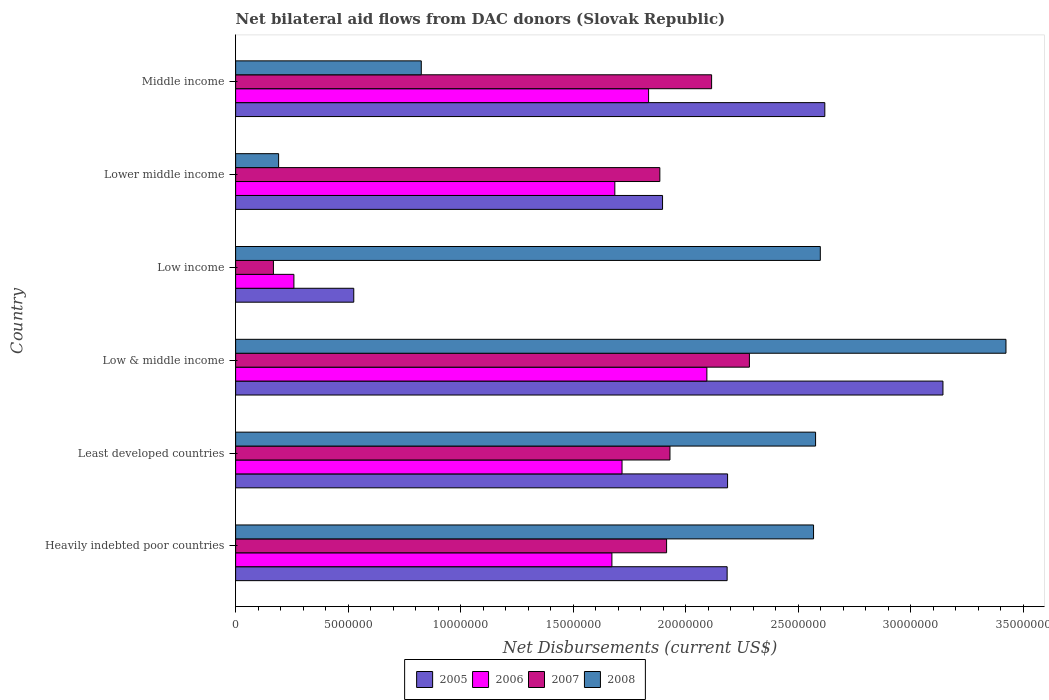How many different coloured bars are there?
Your response must be concise. 4. How many bars are there on the 5th tick from the top?
Provide a short and direct response. 4. How many bars are there on the 6th tick from the bottom?
Your answer should be compact. 4. What is the label of the 3rd group of bars from the top?
Ensure brevity in your answer.  Low income. In how many cases, is the number of bars for a given country not equal to the number of legend labels?
Provide a succinct answer. 0. What is the net bilateral aid flows in 2005 in Low income?
Your answer should be compact. 5.25e+06. Across all countries, what is the maximum net bilateral aid flows in 2005?
Give a very brief answer. 3.14e+07. Across all countries, what is the minimum net bilateral aid flows in 2006?
Offer a very short reply. 2.59e+06. In which country was the net bilateral aid flows in 2007 maximum?
Give a very brief answer. Low & middle income. In which country was the net bilateral aid flows in 2006 minimum?
Your response must be concise. Low income. What is the total net bilateral aid flows in 2007 in the graph?
Offer a terse response. 1.03e+08. What is the difference between the net bilateral aid flows in 2007 in Heavily indebted poor countries and that in Low & middle income?
Your answer should be very brief. -3.68e+06. What is the difference between the net bilateral aid flows in 2008 in Low income and the net bilateral aid flows in 2006 in Low & middle income?
Ensure brevity in your answer.  5.04e+06. What is the average net bilateral aid flows in 2005 per country?
Provide a succinct answer. 2.09e+07. What is the difference between the net bilateral aid flows in 2006 and net bilateral aid flows in 2008 in Middle income?
Give a very brief answer. 1.01e+07. What is the ratio of the net bilateral aid flows in 2008 in Heavily indebted poor countries to that in Middle income?
Provide a short and direct response. 3.11. Is the difference between the net bilateral aid flows in 2006 in Low income and Middle income greater than the difference between the net bilateral aid flows in 2008 in Low income and Middle income?
Offer a terse response. No. What is the difference between the highest and the second highest net bilateral aid flows in 2008?
Offer a terse response. 8.25e+06. What is the difference between the highest and the lowest net bilateral aid flows in 2007?
Your answer should be very brief. 2.12e+07. Is it the case that in every country, the sum of the net bilateral aid flows in 2006 and net bilateral aid flows in 2005 is greater than the sum of net bilateral aid flows in 2008 and net bilateral aid flows in 2007?
Offer a terse response. No. What does the 1st bar from the bottom in Low & middle income represents?
Offer a very short reply. 2005. How many bars are there?
Your answer should be very brief. 24. How many countries are there in the graph?
Keep it short and to the point. 6. Does the graph contain grids?
Make the answer very short. No. How are the legend labels stacked?
Offer a terse response. Horizontal. What is the title of the graph?
Give a very brief answer. Net bilateral aid flows from DAC donors (Slovak Republic). What is the label or title of the X-axis?
Offer a very short reply. Net Disbursements (current US$). What is the Net Disbursements (current US$) in 2005 in Heavily indebted poor countries?
Your response must be concise. 2.18e+07. What is the Net Disbursements (current US$) in 2006 in Heavily indebted poor countries?
Offer a very short reply. 1.67e+07. What is the Net Disbursements (current US$) of 2007 in Heavily indebted poor countries?
Keep it short and to the point. 1.92e+07. What is the Net Disbursements (current US$) in 2008 in Heavily indebted poor countries?
Keep it short and to the point. 2.57e+07. What is the Net Disbursements (current US$) in 2005 in Least developed countries?
Your response must be concise. 2.19e+07. What is the Net Disbursements (current US$) in 2006 in Least developed countries?
Give a very brief answer. 1.72e+07. What is the Net Disbursements (current US$) of 2007 in Least developed countries?
Provide a short and direct response. 1.93e+07. What is the Net Disbursements (current US$) in 2008 in Least developed countries?
Your answer should be compact. 2.58e+07. What is the Net Disbursements (current US$) of 2005 in Low & middle income?
Offer a terse response. 3.14e+07. What is the Net Disbursements (current US$) of 2006 in Low & middle income?
Your answer should be very brief. 2.09e+07. What is the Net Disbursements (current US$) of 2007 in Low & middle income?
Keep it short and to the point. 2.28e+07. What is the Net Disbursements (current US$) of 2008 in Low & middle income?
Provide a succinct answer. 3.42e+07. What is the Net Disbursements (current US$) of 2005 in Low income?
Provide a short and direct response. 5.25e+06. What is the Net Disbursements (current US$) in 2006 in Low income?
Give a very brief answer. 2.59e+06. What is the Net Disbursements (current US$) of 2007 in Low income?
Give a very brief answer. 1.68e+06. What is the Net Disbursements (current US$) in 2008 in Low income?
Give a very brief answer. 2.60e+07. What is the Net Disbursements (current US$) of 2005 in Lower middle income?
Ensure brevity in your answer.  1.90e+07. What is the Net Disbursements (current US$) in 2006 in Lower middle income?
Give a very brief answer. 1.68e+07. What is the Net Disbursements (current US$) of 2007 in Lower middle income?
Your response must be concise. 1.88e+07. What is the Net Disbursements (current US$) in 2008 in Lower middle income?
Your answer should be compact. 1.91e+06. What is the Net Disbursements (current US$) in 2005 in Middle income?
Provide a short and direct response. 2.62e+07. What is the Net Disbursements (current US$) of 2006 in Middle income?
Give a very brief answer. 1.84e+07. What is the Net Disbursements (current US$) of 2007 in Middle income?
Provide a succinct answer. 2.12e+07. What is the Net Disbursements (current US$) in 2008 in Middle income?
Keep it short and to the point. 8.25e+06. Across all countries, what is the maximum Net Disbursements (current US$) of 2005?
Your response must be concise. 3.14e+07. Across all countries, what is the maximum Net Disbursements (current US$) of 2006?
Keep it short and to the point. 2.09e+07. Across all countries, what is the maximum Net Disbursements (current US$) in 2007?
Offer a terse response. 2.28e+07. Across all countries, what is the maximum Net Disbursements (current US$) in 2008?
Provide a short and direct response. 3.42e+07. Across all countries, what is the minimum Net Disbursements (current US$) of 2005?
Make the answer very short. 5.25e+06. Across all countries, what is the minimum Net Disbursements (current US$) in 2006?
Offer a very short reply. 2.59e+06. Across all countries, what is the minimum Net Disbursements (current US$) of 2007?
Your answer should be very brief. 1.68e+06. Across all countries, what is the minimum Net Disbursements (current US$) of 2008?
Ensure brevity in your answer.  1.91e+06. What is the total Net Disbursements (current US$) in 2005 in the graph?
Offer a terse response. 1.26e+08. What is the total Net Disbursements (current US$) in 2006 in the graph?
Offer a very short reply. 9.26e+07. What is the total Net Disbursements (current US$) in 2007 in the graph?
Your response must be concise. 1.03e+08. What is the total Net Disbursements (current US$) in 2008 in the graph?
Provide a short and direct response. 1.22e+08. What is the difference between the Net Disbursements (current US$) of 2006 in Heavily indebted poor countries and that in Least developed countries?
Your answer should be compact. -4.50e+05. What is the difference between the Net Disbursements (current US$) in 2008 in Heavily indebted poor countries and that in Least developed countries?
Give a very brief answer. -9.00e+04. What is the difference between the Net Disbursements (current US$) in 2005 in Heavily indebted poor countries and that in Low & middle income?
Make the answer very short. -9.59e+06. What is the difference between the Net Disbursements (current US$) of 2006 in Heavily indebted poor countries and that in Low & middle income?
Your response must be concise. -4.22e+06. What is the difference between the Net Disbursements (current US$) in 2007 in Heavily indebted poor countries and that in Low & middle income?
Make the answer very short. -3.68e+06. What is the difference between the Net Disbursements (current US$) in 2008 in Heavily indebted poor countries and that in Low & middle income?
Your response must be concise. -8.55e+06. What is the difference between the Net Disbursements (current US$) in 2005 in Heavily indebted poor countries and that in Low income?
Your response must be concise. 1.66e+07. What is the difference between the Net Disbursements (current US$) in 2006 in Heavily indebted poor countries and that in Low income?
Your answer should be compact. 1.41e+07. What is the difference between the Net Disbursements (current US$) in 2007 in Heavily indebted poor countries and that in Low income?
Your answer should be very brief. 1.75e+07. What is the difference between the Net Disbursements (current US$) of 2008 in Heavily indebted poor countries and that in Low income?
Make the answer very short. -3.00e+05. What is the difference between the Net Disbursements (current US$) of 2005 in Heavily indebted poor countries and that in Lower middle income?
Give a very brief answer. 2.87e+06. What is the difference between the Net Disbursements (current US$) of 2006 in Heavily indebted poor countries and that in Lower middle income?
Keep it short and to the point. -1.30e+05. What is the difference between the Net Disbursements (current US$) in 2008 in Heavily indebted poor countries and that in Lower middle income?
Your response must be concise. 2.38e+07. What is the difference between the Net Disbursements (current US$) of 2005 in Heavily indebted poor countries and that in Middle income?
Make the answer very short. -4.34e+06. What is the difference between the Net Disbursements (current US$) in 2006 in Heavily indebted poor countries and that in Middle income?
Offer a terse response. -1.63e+06. What is the difference between the Net Disbursements (current US$) in 2008 in Heavily indebted poor countries and that in Middle income?
Your answer should be very brief. 1.74e+07. What is the difference between the Net Disbursements (current US$) of 2005 in Least developed countries and that in Low & middle income?
Your answer should be compact. -9.57e+06. What is the difference between the Net Disbursements (current US$) in 2006 in Least developed countries and that in Low & middle income?
Your response must be concise. -3.77e+06. What is the difference between the Net Disbursements (current US$) of 2007 in Least developed countries and that in Low & middle income?
Give a very brief answer. -3.53e+06. What is the difference between the Net Disbursements (current US$) of 2008 in Least developed countries and that in Low & middle income?
Keep it short and to the point. -8.46e+06. What is the difference between the Net Disbursements (current US$) of 2005 in Least developed countries and that in Low income?
Your answer should be very brief. 1.66e+07. What is the difference between the Net Disbursements (current US$) of 2006 in Least developed countries and that in Low income?
Your response must be concise. 1.46e+07. What is the difference between the Net Disbursements (current US$) in 2007 in Least developed countries and that in Low income?
Keep it short and to the point. 1.76e+07. What is the difference between the Net Disbursements (current US$) of 2005 in Least developed countries and that in Lower middle income?
Your answer should be very brief. 2.89e+06. What is the difference between the Net Disbursements (current US$) of 2006 in Least developed countries and that in Lower middle income?
Provide a succinct answer. 3.20e+05. What is the difference between the Net Disbursements (current US$) of 2008 in Least developed countries and that in Lower middle income?
Your answer should be compact. 2.39e+07. What is the difference between the Net Disbursements (current US$) of 2005 in Least developed countries and that in Middle income?
Your answer should be very brief. -4.32e+06. What is the difference between the Net Disbursements (current US$) of 2006 in Least developed countries and that in Middle income?
Offer a very short reply. -1.18e+06. What is the difference between the Net Disbursements (current US$) in 2007 in Least developed countries and that in Middle income?
Offer a very short reply. -1.85e+06. What is the difference between the Net Disbursements (current US$) of 2008 in Least developed countries and that in Middle income?
Your answer should be compact. 1.75e+07. What is the difference between the Net Disbursements (current US$) in 2005 in Low & middle income and that in Low income?
Offer a terse response. 2.62e+07. What is the difference between the Net Disbursements (current US$) in 2006 in Low & middle income and that in Low income?
Keep it short and to the point. 1.84e+07. What is the difference between the Net Disbursements (current US$) in 2007 in Low & middle income and that in Low income?
Offer a terse response. 2.12e+07. What is the difference between the Net Disbursements (current US$) in 2008 in Low & middle income and that in Low income?
Offer a very short reply. 8.25e+06. What is the difference between the Net Disbursements (current US$) in 2005 in Low & middle income and that in Lower middle income?
Your answer should be very brief. 1.25e+07. What is the difference between the Net Disbursements (current US$) of 2006 in Low & middle income and that in Lower middle income?
Offer a very short reply. 4.09e+06. What is the difference between the Net Disbursements (current US$) in 2007 in Low & middle income and that in Lower middle income?
Offer a terse response. 3.98e+06. What is the difference between the Net Disbursements (current US$) of 2008 in Low & middle income and that in Lower middle income?
Provide a succinct answer. 3.23e+07. What is the difference between the Net Disbursements (current US$) of 2005 in Low & middle income and that in Middle income?
Give a very brief answer. 5.25e+06. What is the difference between the Net Disbursements (current US$) in 2006 in Low & middle income and that in Middle income?
Offer a terse response. 2.59e+06. What is the difference between the Net Disbursements (current US$) in 2007 in Low & middle income and that in Middle income?
Offer a very short reply. 1.68e+06. What is the difference between the Net Disbursements (current US$) of 2008 in Low & middle income and that in Middle income?
Provide a succinct answer. 2.60e+07. What is the difference between the Net Disbursements (current US$) in 2005 in Low income and that in Lower middle income?
Make the answer very short. -1.37e+07. What is the difference between the Net Disbursements (current US$) of 2006 in Low income and that in Lower middle income?
Make the answer very short. -1.43e+07. What is the difference between the Net Disbursements (current US$) of 2007 in Low income and that in Lower middle income?
Give a very brief answer. -1.72e+07. What is the difference between the Net Disbursements (current US$) in 2008 in Low income and that in Lower middle income?
Your answer should be compact. 2.41e+07. What is the difference between the Net Disbursements (current US$) in 2005 in Low income and that in Middle income?
Your answer should be very brief. -2.09e+07. What is the difference between the Net Disbursements (current US$) in 2006 in Low income and that in Middle income?
Offer a terse response. -1.58e+07. What is the difference between the Net Disbursements (current US$) in 2007 in Low income and that in Middle income?
Your response must be concise. -1.95e+07. What is the difference between the Net Disbursements (current US$) of 2008 in Low income and that in Middle income?
Make the answer very short. 1.77e+07. What is the difference between the Net Disbursements (current US$) in 2005 in Lower middle income and that in Middle income?
Your response must be concise. -7.21e+06. What is the difference between the Net Disbursements (current US$) in 2006 in Lower middle income and that in Middle income?
Keep it short and to the point. -1.50e+06. What is the difference between the Net Disbursements (current US$) of 2007 in Lower middle income and that in Middle income?
Keep it short and to the point. -2.30e+06. What is the difference between the Net Disbursements (current US$) in 2008 in Lower middle income and that in Middle income?
Make the answer very short. -6.34e+06. What is the difference between the Net Disbursements (current US$) in 2005 in Heavily indebted poor countries and the Net Disbursements (current US$) in 2006 in Least developed countries?
Give a very brief answer. 4.67e+06. What is the difference between the Net Disbursements (current US$) in 2005 in Heavily indebted poor countries and the Net Disbursements (current US$) in 2007 in Least developed countries?
Provide a succinct answer. 2.54e+06. What is the difference between the Net Disbursements (current US$) in 2005 in Heavily indebted poor countries and the Net Disbursements (current US$) in 2008 in Least developed countries?
Your response must be concise. -3.93e+06. What is the difference between the Net Disbursements (current US$) of 2006 in Heavily indebted poor countries and the Net Disbursements (current US$) of 2007 in Least developed countries?
Your response must be concise. -2.58e+06. What is the difference between the Net Disbursements (current US$) of 2006 in Heavily indebted poor countries and the Net Disbursements (current US$) of 2008 in Least developed countries?
Provide a succinct answer. -9.05e+06. What is the difference between the Net Disbursements (current US$) of 2007 in Heavily indebted poor countries and the Net Disbursements (current US$) of 2008 in Least developed countries?
Offer a very short reply. -6.62e+06. What is the difference between the Net Disbursements (current US$) of 2005 in Heavily indebted poor countries and the Net Disbursements (current US$) of 2006 in Low & middle income?
Provide a short and direct response. 9.00e+05. What is the difference between the Net Disbursements (current US$) of 2005 in Heavily indebted poor countries and the Net Disbursements (current US$) of 2007 in Low & middle income?
Offer a terse response. -9.90e+05. What is the difference between the Net Disbursements (current US$) in 2005 in Heavily indebted poor countries and the Net Disbursements (current US$) in 2008 in Low & middle income?
Provide a short and direct response. -1.24e+07. What is the difference between the Net Disbursements (current US$) in 2006 in Heavily indebted poor countries and the Net Disbursements (current US$) in 2007 in Low & middle income?
Your response must be concise. -6.11e+06. What is the difference between the Net Disbursements (current US$) in 2006 in Heavily indebted poor countries and the Net Disbursements (current US$) in 2008 in Low & middle income?
Keep it short and to the point. -1.75e+07. What is the difference between the Net Disbursements (current US$) of 2007 in Heavily indebted poor countries and the Net Disbursements (current US$) of 2008 in Low & middle income?
Your response must be concise. -1.51e+07. What is the difference between the Net Disbursements (current US$) of 2005 in Heavily indebted poor countries and the Net Disbursements (current US$) of 2006 in Low income?
Offer a terse response. 1.92e+07. What is the difference between the Net Disbursements (current US$) of 2005 in Heavily indebted poor countries and the Net Disbursements (current US$) of 2007 in Low income?
Give a very brief answer. 2.02e+07. What is the difference between the Net Disbursements (current US$) of 2005 in Heavily indebted poor countries and the Net Disbursements (current US$) of 2008 in Low income?
Give a very brief answer. -4.14e+06. What is the difference between the Net Disbursements (current US$) of 2006 in Heavily indebted poor countries and the Net Disbursements (current US$) of 2007 in Low income?
Offer a terse response. 1.50e+07. What is the difference between the Net Disbursements (current US$) in 2006 in Heavily indebted poor countries and the Net Disbursements (current US$) in 2008 in Low income?
Your answer should be compact. -9.26e+06. What is the difference between the Net Disbursements (current US$) of 2007 in Heavily indebted poor countries and the Net Disbursements (current US$) of 2008 in Low income?
Your answer should be compact. -6.83e+06. What is the difference between the Net Disbursements (current US$) of 2005 in Heavily indebted poor countries and the Net Disbursements (current US$) of 2006 in Lower middle income?
Provide a short and direct response. 4.99e+06. What is the difference between the Net Disbursements (current US$) in 2005 in Heavily indebted poor countries and the Net Disbursements (current US$) in 2007 in Lower middle income?
Your response must be concise. 2.99e+06. What is the difference between the Net Disbursements (current US$) in 2005 in Heavily indebted poor countries and the Net Disbursements (current US$) in 2008 in Lower middle income?
Your response must be concise. 1.99e+07. What is the difference between the Net Disbursements (current US$) of 2006 in Heavily indebted poor countries and the Net Disbursements (current US$) of 2007 in Lower middle income?
Your answer should be very brief. -2.13e+06. What is the difference between the Net Disbursements (current US$) of 2006 in Heavily indebted poor countries and the Net Disbursements (current US$) of 2008 in Lower middle income?
Make the answer very short. 1.48e+07. What is the difference between the Net Disbursements (current US$) of 2007 in Heavily indebted poor countries and the Net Disbursements (current US$) of 2008 in Lower middle income?
Keep it short and to the point. 1.72e+07. What is the difference between the Net Disbursements (current US$) of 2005 in Heavily indebted poor countries and the Net Disbursements (current US$) of 2006 in Middle income?
Your answer should be compact. 3.49e+06. What is the difference between the Net Disbursements (current US$) of 2005 in Heavily indebted poor countries and the Net Disbursements (current US$) of 2007 in Middle income?
Your response must be concise. 6.90e+05. What is the difference between the Net Disbursements (current US$) of 2005 in Heavily indebted poor countries and the Net Disbursements (current US$) of 2008 in Middle income?
Provide a short and direct response. 1.36e+07. What is the difference between the Net Disbursements (current US$) in 2006 in Heavily indebted poor countries and the Net Disbursements (current US$) in 2007 in Middle income?
Keep it short and to the point. -4.43e+06. What is the difference between the Net Disbursements (current US$) of 2006 in Heavily indebted poor countries and the Net Disbursements (current US$) of 2008 in Middle income?
Provide a short and direct response. 8.47e+06. What is the difference between the Net Disbursements (current US$) of 2007 in Heavily indebted poor countries and the Net Disbursements (current US$) of 2008 in Middle income?
Keep it short and to the point. 1.09e+07. What is the difference between the Net Disbursements (current US$) of 2005 in Least developed countries and the Net Disbursements (current US$) of 2006 in Low & middle income?
Your response must be concise. 9.20e+05. What is the difference between the Net Disbursements (current US$) of 2005 in Least developed countries and the Net Disbursements (current US$) of 2007 in Low & middle income?
Your answer should be very brief. -9.70e+05. What is the difference between the Net Disbursements (current US$) in 2005 in Least developed countries and the Net Disbursements (current US$) in 2008 in Low & middle income?
Ensure brevity in your answer.  -1.24e+07. What is the difference between the Net Disbursements (current US$) in 2006 in Least developed countries and the Net Disbursements (current US$) in 2007 in Low & middle income?
Your answer should be compact. -5.66e+06. What is the difference between the Net Disbursements (current US$) of 2006 in Least developed countries and the Net Disbursements (current US$) of 2008 in Low & middle income?
Make the answer very short. -1.71e+07. What is the difference between the Net Disbursements (current US$) of 2007 in Least developed countries and the Net Disbursements (current US$) of 2008 in Low & middle income?
Keep it short and to the point. -1.49e+07. What is the difference between the Net Disbursements (current US$) in 2005 in Least developed countries and the Net Disbursements (current US$) in 2006 in Low income?
Make the answer very short. 1.93e+07. What is the difference between the Net Disbursements (current US$) in 2005 in Least developed countries and the Net Disbursements (current US$) in 2007 in Low income?
Your response must be concise. 2.02e+07. What is the difference between the Net Disbursements (current US$) of 2005 in Least developed countries and the Net Disbursements (current US$) of 2008 in Low income?
Ensure brevity in your answer.  -4.12e+06. What is the difference between the Net Disbursements (current US$) of 2006 in Least developed countries and the Net Disbursements (current US$) of 2007 in Low income?
Give a very brief answer. 1.55e+07. What is the difference between the Net Disbursements (current US$) in 2006 in Least developed countries and the Net Disbursements (current US$) in 2008 in Low income?
Make the answer very short. -8.81e+06. What is the difference between the Net Disbursements (current US$) of 2007 in Least developed countries and the Net Disbursements (current US$) of 2008 in Low income?
Keep it short and to the point. -6.68e+06. What is the difference between the Net Disbursements (current US$) in 2005 in Least developed countries and the Net Disbursements (current US$) in 2006 in Lower middle income?
Give a very brief answer. 5.01e+06. What is the difference between the Net Disbursements (current US$) in 2005 in Least developed countries and the Net Disbursements (current US$) in 2007 in Lower middle income?
Keep it short and to the point. 3.01e+06. What is the difference between the Net Disbursements (current US$) of 2005 in Least developed countries and the Net Disbursements (current US$) of 2008 in Lower middle income?
Keep it short and to the point. 2.00e+07. What is the difference between the Net Disbursements (current US$) of 2006 in Least developed countries and the Net Disbursements (current US$) of 2007 in Lower middle income?
Your answer should be very brief. -1.68e+06. What is the difference between the Net Disbursements (current US$) of 2006 in Least developed countries and the Net Disbursements (current US$) of 2008 in Lower middle income?
Offer a very short reply. 1.53e+07. What is the difference between the Net Disbursements (current US$) in 2007 in Least developed countries and the Net Disbursements (current US$) in 2008 in Lower middle income?
Your response must be concise. 1.74e+07. What is the difference between the Net Disbursements (current US$) in 2005 in Least developed countries and the Net Disbursements (current US$) in 2006 in Middle income?
Offer a very short reply. 3.51e+06. What is the difference between the Net Disbursements (current US$) in 2005 in Least developed countries and the Net Disbursements (current US$) in 2007 in Middle income?
Offer a very short reply. 7.10e+05. What is the difference between the Net Disbursements (current US$) in 2005 in Least developed countries and the Net Disbursements (current US$) in 2008 in Middle income?
Provide a short and direct response. 1.36e+07. What is the difference between the Net Disbursements (current US$) of 2006 in Least developed countries and the Net Disbursements (current US$) of 2007 in Middle income?
Offer a very short reply. -3.98e+06. What is the difference between the Net Disbursements (current US$) in 2006 in Least developed countries and the Net Disbursements (current US$) in 2008 in Middle income?
Keep it short and to the point. 8.92e+06. What is the difference between the Net Disbursements (current US$) in 2007 in Least developed countries and the Net Disbursements (current US$) in 2008 in Middle income?
Make the answer very short. 1.10e+07. What is the difference between the Net Disbursements (current US$) in 2005 in Low & middle income and the Net Disbursements (current US$) in 2006 in Low income?
Make the answer very short. 2.88e+07. What is the difference between the Net Disbursements (current US$) in 2005 in Low & middle income and the Net Disbursements (current US$) in 2007 in Low income?
Offer a very short reply. 2.98e+07. What is the difference between the Net Disbursements (current US$) of 2005 in Low & middle income and the Net Disbursements (current US$) of 2008 in Low income?
Make the answer very short. 5.45e+06. What is the difference between the Net Disbursements (current US$) in 2006 in Low & middle income and the Net Disbursements (current US$) in 2007 in Low income?
Provide a succinct answer. 1.93e+07. What is the difference between the Net Disbursements (current US$) in 2006 in Low & middle income and the Net Disbursements (current US$) in 2008 in Low income?
Your answer should be very brief. -5.04e+06. What is the difference between the Net Disbursements (current US$) of 2007 in Low & middle income and the Net Disbursements (current US$) of 2008 in Low income?
Provide a short and direct response. -3.15e+06. What is the difference between the Net Disbursements (current US$) in 2005 in Low & middle income and the Net Disbursements (current US$) in 2006 in Lower middle income?
Provide a succinct answer. 1.46e+07. What is the difference between the Net Disbursements (current US$) in 2005 in Low & middle income and the Net Disbursements (current US$) in 2007 in Lower middle income?
Ensure brevity in your answer.  1.26e+07. What is the difference between the Net Disbursements (current US$) of 2005 in Low & middle income and the Net Disbursements (current US$) of 2008 in Lower middle income?
Offer a terse response. 2.95e+07. What is the difference between the Net Disbursements (current US$) of 2006 in Low & middle income and the Net Disbursements (current US$) of 2007 in Lower middle income?
Your response must be concise. 2.09e+06. What is the difference between the Net Disbursements (current US$) of 2006 in Low & middle income and the Net Disbursements (current US$) of 2008 in Lower middle income?
Your answer should be compact. 1.90e+07. What is the difference between the Net Disbursements (current US$) of 2007 in Low & middle income and the Net Disbursements (current US$) of 2008 in Lower middle income?
Your response must be concise. 2.09e+07. What is the difference between the Net Disbursements (current US$) of 2005 in Low & middle income and the Net Disbursements (current US$) of 2006 in Middle income?
Give a very brief answer. 1.31e+07. What is the difference between the Net Disbursements (current US$) in 2005 in Low & middle income and the Net Disbursements (current US$) in 2007 in Middle income?
Offer a terse response. 1.03e+07. What is the difference between the Net Disbursements (current US$) of 2005 in Low & middle income and the Net Disbursements (current US$) of 2008 in Middle income?
Ensure brevity in your answer.  2.32e+07. What is the difference between the Net Disbursements (current US$) in 2006 in Low & middle income and the Net Disbursements (current US$) in 2008 in Middle income?
Keep it short and to the point. 1.27e+07. What is the difference between the Net Disbursements (current US$) of 2007 in Low & middle income and the Net Disbursements (current US$) of 2008 in Middle income?
Offer a very short reply. 1.46e+07. What is the difference between the Net Disbursements (current US$) of 2005 in Low income and the Net Disbursements (current US$) of 2006 in Lower middle income?
Make the answer very short. -1.16e+07. What is the difference between the Net Disbursements (current US$) of 2005 in Low income and the Net Disbursements (current US$) of 2007 in Lower middle income?
Offer a very short reply. -1.36e+07. What is the difference between the Net Disbursements (current US$) in 2005 in Low income and the Net Disbursements (current US$) in 2008 in Lower middle income?
Your response must be concise. 3.34e+06. What is the difference between the Net Disbursements (current US$) of 2006 in Low income and the Net Disbursements (current US$) of 2007 in Lower middle income?
Your answer should be compact. -1.63e+07. What is the difference between the Net Disbursements (current US$) in 2006 in Low income and the Net Disbursements (current US$) in 2008 in Lower middle income?
Offer a very short reply. 6.80e+05. What is the difference between the Net Disbursements (current US$) in 2007 in Low income and the Net Disbursements (current US$) in 2008 in Lower middle income?
Offer a terse response. -2.30e+05. What is the difference between the Net Disbursements (current US$) in 2005 in Low income and the Net Disbursements (current US$) in 2006 in Middle income?
Provide a short and direct response. -1.31e+07. What is the difference between the Net Disbursements (current US$) in 2005 in Low income and the Net Disbursements (current US$) in 2007 in Middle income?
Ensure brevity in your answer.  -1.59e+07. What is the difference between the Net Disbursements (current US$) in 2006 in Low income and the Net Disbursements (current US$) in 2007 in Middle income?
Offer a terse response. -1.86e+07. What is the difference between the Net Disbursements (current US$) of 2006 in Low income and the Net Disbursements (current US$) of 2008 in Middle income?
Keep it short and to the point. -5.66e+06. What is the difference between the Net Disbursements (current US$) of 2007 in Low income and the Net Disbursements (current US$) of 2008 in Middle income?
Your response must be concise. -6.57e+06. What is the difference between the Net Disbursements (current US$) in 2005 in Lower middle income and the Net Disbursements (current US$) in 2006 in Middle income?
Provide a short and direct response. 6.20e+05. What is the difference between the Net Disbursements (current US$) in 2005 in Lower middle income and the Net Disbursements (current US$) in 2007 in Middle income?
Offer a very short reply. -2.18e+06. What is the difference between the Net Disbursements (current US$) of 2005 in Lower middle income and the Net Disbursements (current US$) of 2008 in Middle income?
Your answer should be compact. 1.07e+07. What is the difference between the Net Disbursements (current US$) in 2006 in Lower middle income and the Net Disbursements (current US$) in 2007 in Middle income?
Keep it short and to the point. -4.30e+06. What is the difference between the Net Disbursements (current US$) of 2006 in Lower middle income and the Net Disbursements (current US$) of 2008 in Middle income?
Your response must be concise. 8.60e+06. What is the difference between the Net Disbursements (current US$) in 2007 in Lower middle income and the Net Disbursements (current US$) in 2008 in Middle income?
Give a very brief answer. 1.06e+07. What is the average Net Disbursements (current US$) in 2005 per country?
Provide a short and direct response. 2.09e+07. What is the average Net Disbursements (current US$) of 2006 per country?
Your answer should be very brief. 1.54e+07. What is the average Net Disbursements (current US$) of 2007 per country?
Provide a short and direct response. 1.72e+07. What is the average Net Disbursements (current US$) of 2008 per country?
Make the answer very short. 2.03e+07. What is the difference between the Net Disbursements (current US$) in 2005 and Net Disbursements (current US$) in 2006 in Heavily indebted poor countries?
Provide a short and direct response. 5.12e+06. What is the difference between the Net Disbursements (current US$) of 2005 and Net Disbursements (current US$) of 2007 in Heavily indebted poor countries?
Provide a succinct answer. 2.69e+06. What is the difference between the Net Disbursements (current US$) of 2005 and Net Disbursements (current US$) of 2008 in Heavily indebted poor countries?
Your answer should be compact. -3.84e+06. What is the difference between the Net Disbursements (current US$) of 2006 and Net Disbursements (current US$) of 2007 in Heavily indebted poor countries?
Provide a succinct answer. -2.43e+06. What is the difference between the Net Disbursements (current US$) in 2006 and Net Disbursements (current US$) in 2008 in Heavily indebted poor countries?
Provide a succinct answer. -8.96e+06. What is the difference between the Net Disbursements (current US$) of 2007 and Net Disbursements (current US$) of 2008 in Heavily indebted poor countries?
Ensure brevity in your answer.  -6.53e+06. What is the difference between the Net Disbursements (current US$) in 2005 and Net Disbursements (current US$) in 2006 in Least developed countries?
Keep it short and to the point. 4.69e+06. What is the difference between the Net Disbursements (current US$) in 2005 and Net Disbursements (current US$) in 2007 in Least developed countries?
Make the answer very short. 2.56e+06. What is the difference between the Net Disbursements (current US$) of 2005 and Net Disbursements (current US$) of 2008 in Least developed countries?
Provide a short and direct response. -3.91e+06. What is the difference between the Net Disbursements (current US$) in 2006 and Net Disbursements (current US$) in 2007 in Least developed countries?
Provide a short and direct response. -2.13e+06. What is the difference between the Net Disbursements (current US$) of 2006 and Net Disbursements (current US$) of 2008 in Least developed countries?
Provide a succinct answer. -8.60e+06. What is the difference between the Net Disbursements (current US$) of 2007 and Net Disbursements (current US$) of 2008 in Least developed countries?
Your answer should be compact. -6.47e+06. What is the difference between the Net Disbursements (current US$) of 2005 and Net Disbursements (current US$) of 2006 in Low & middle income?
Your answer should be very brief. 1.05e+07. What is the difference between the Net Disbursements (current US$) of 2005 and Net Disbursements (current US$) of 2007 in Low & middle income?
Offer a very short reply. 8.60e+06. What is the difference between the Net Disbursements (current US$) in 2005 and Net Disbursements (current US$) in 2008 in Low & middle income?
Offer a very short reply. -2.80e+06. What is the difference between the Net Disbursements (current US$) of 2006 and Net Disbursements (current US$) of 2007 in Low & middle income?
Make the answer very short. -1.89e+06. What is the difference between the Net Disbursements (current US$) of 2006 and Net Disbursements (current US$) of 2008 in Low & middle income?
Keep it short and to the point. -1.33e+07. What is the difference between the Net Disbursements (current US$) in 2007 and Net Disbursements (current US$) in 2008 in Low & middle income?
Make the answer very short. -1.14e+07. What is the difference between the Net Disbursements (current US$) of 2005 and Net Disbursements (current US$) of 2006 in Low income?
Keep it short and to the point. 2.66e+06. What is the difference between the Net Disbursements (current US$) of 2005 and Net Disbursements (current US$) of 2007 in Low income?
Give a very brief answer. 3.57e+06. What is the difference between the Net Disbursements (current US$) in 2005 and Net Disbursements (current US$) in 2008 in Low income?
Your answer should be compact. -2.07e+07. What is the difference between the Net Disbursements (current US$) in 2006 and Net Disbursements (current US$) in 2007 in Low income?
Keep it short and to the point. 9.10e+05. What is the difference between the Net Disbursements (current US$) in 2006 and Net Disbursements (current US$) in 2008 in Low income?
Make the answer very short. -2.34e+07. What is the difference between the Net Disbursements (current US$) of 2007 and Net Disbursements (current US$) of 2008 in Low income?
Make the answer very short. -2.43e+07. What is the difference between the Net Disbursements (current US$) of 2005 and Net Disbursements (current US$) of 2006 in Lower middle income?
Provide a succinct answer. 2.12e+06. What is the difference between the Net Disbursements (current US$) in 2005 and Net Disbursements (current US$) in 2007 in Lower middle income?
Ensure brevity in your answer.  1.20e+05. What is the difference between the Net Disbursements (current US$) in 2005 and Net Disbursements (current US$) in 2008 in Lower middle income?
Ensure brevity in your answer.  1.71e+07. What is the difference between the Net Disbursements (current US$) in 2006 and Net Disbursements (current US$) in 2008 in Lower middle income?
Provide a short and direct response. 1.49e+07. What is the difference between the Net Disbursements (current US$) in 2007 and Net Disbursements (current US$) in 2008 in Lower middle income?
Make the answer very short. 1.69e+07. What is the difference between the Net Disbursements (current US$) in 2005 and Net Disbursements (current US$) in 2006 in Middle income?
Your response must be concise. 7.83e+06. What is the difference between the Net Disbursements (current US$) in 2005 and Net Disbursements (current US$) in 2007 in Middle income?
Offer a terse response. 5.03e+06. What is the difference between the Net Disbursements (current US$) in 2005 and Net Disbursements (current US$) in 2008 in Middle income?
Provide a succinct answer. 1.79e+07. What is the difference between the Net Disbursements (current US$) of 2006 and Net Disbursements (current US$) of 2007 in Middle income?
Make the answer very short. -2.80e+06. What is the difference between the Net Disbursements (current US$) of 2006 and Net Disbursements (current US$) of 2008 in Middle income?
Give a very brief answer. 1.01e+07. What is the difference between the Net Disbursements (current US$) in 2007 and Net Disbursements (current US$) in 2008 in Middle income?
Your response must be concise. 1.29e+07. What is the ratio of the Net Disbursements (current US$) of 2005 in Heavily indebted poor countries to that in Least developed countries?
Keep it short and to the point. 1. What is the ratio of the Net Disbursements (current US$) of 2006 in Heavily indebted poor countries to that in Least developed countries?
Ensure brevity in your answer.  0.97. What is the ratio of the Net Disbursements (current US$) in 2007 in Heavily indebted poor countries to that in Least developed countries?
Your response must be concise. 0.99. What is the ratio of the Net Disbursements (current US$) of 2005 in Heavily indebted poor countries to that in Low & middle income?
Provide a short and direct response. 0.69. What is the ratio of the Net Disbursements (current US$) of 2006 in Heavily indebted poor countries to that in Low & middle income?
Provide a short and direct response. 0.8. What is the ratio of the Net Disbursements (current US$) in 2007 in Heavily indebted poor countries to that in Low & middle income?
Offer a terse response. 0.84. What is the ratio of the Net Disbursements (current US$) in 2008 in Heavily indebted poor countries to that in Low & middle income?
Offer a terse response. 0.75. What is the ratio of the Net Disbursements (current US$) in 2005 in Heavily indebted poor countries to that in Low income?
Offer a very short reply. 4.16. What is the ratio of the Net Disbursements (current US$) in 2006 in Heavily indebted poor countries to that in Low income?
Ensure brevity in your answer.  6.46. What is the ratio of the Net Disbursements (current US$) in 2007 in Heavily indebted poor countries to that in Low income?
Offer a very short reply. 11.4. What is the ratio of the Net Disbursements (current US$) of 2005 in Heavily indebted poor countries to that in Lower middle income?
Your answer should be very brief. 1.15. What is the ratio of the Net Disbursements (current US$) of 2007 in Heavily indebted poor countries to that in Lower middle income?
Provide a short and direct response. 1.02. What is the ratio of the Net Disbursements (current US$) of 2008 in Heavily indebted poor countries to that in Lower middle income?
Keep it short and to the point. 13.45. What is the ratio of the Net Disbursements (current US$) in 2005 in Heavily indebted poor countries to that in Middle income?
Provide a short and direct response. 0.83. What is the ratio of the Net Disbursements (current US$) of 2006 in Heavily indebted poor countries to that in Middle income?
Your answer should be very brief. 0.91. What is the ratio of the Net Disbursements (current US$) of 2007 in Heavily indebted poor countries to that in Middle income?
Ensure brevity in your answer.  0.91. What is the ratio of the Net Disbursements (current US$) in 2008 in Heavily indebted poor countries to that in Middle income?
Provide a succinct answer. 3.11. What is the ratio of the Net Disbursements (current US$) in 2005 in Least developed countries to that in Low & middle income?
Your answer should be compact. 0.7. What is the ratio of the Net Disbursements (current US$) of 2006 in Least developed countries to that in Low & middle income?
Your answer should be very brief. 0.82. What is the ratio of the Net Disbursements (current US$) in 2007 in Least developed countries to that in Low & middle income?
Provide a succinct answer. 0.85. What is the ratio of the Net Disbursements (current US$) in 2008 in Least developed countries to that in Low & middle income?
Keep it short and to the point. 0.75. What is the ratio of the Net Disbursements (current US$) in 2005 in Least developed countries to that in Low income?
Offer a terse response. 4.16. What is the ratio of the Net Disbursements (current US$) in 2006 in Least developed countries to that in Low income?
Give a very brief answer. 6.63. What is the ratio of the Net Disbursements (current US$) of 2007 in Least developed countries to that in Low income?
Provide a short and direct response. 11.49. What is the ratio of the Net Disbursements (current US$) of 2005 in Least developed countries to that in Lower middle income?
Offer a terse response. 1.15. What is the ratio of the Net Disbursements (current US$) of 2007 in Least developed countries to that in Lower middle income?
Offer a terse response. 1.02. What is the ratio of the Net Disbursements (current US$) of 2008 in Least developed countries to that in Lower middle income?
Offer a terse response. 13.49. What is the ratio of the Net Disbursements (current US$) in 2005 in Least developed countries to that in Middle income?
Offer a terse response. 0.83. What is the ratio of the Net Disbursements (current US$) of 2006 in Least developed countries to that in Middle income?
Make the answer very short. 0.94. What is the ratio of the Net Disbursements (current US$) of 2007 in Least developed countries to that in Middle income?
Keep it short and to the point. 0.91. What is the ratio of the Net Disbursements (current US$) in 2008 in Least developed countries to that in Middle income?
Your answer should be compact. 3.12. What is the ratio of the Net Disbursements (current US$) of 2005 in Low & middle income to that in Low income?
Your answer should be very brief. 5.99. What is the ratio of the Net Disbursements (current US$) in 2006 in Low & middle income to that in Low income?
Provide a short and direct response. 8.08. What is the ratio of the Net Disbursements (current US$) in 2007 in Low & middle income to that in Low income?
Your answer should be very brief. 13.59. What is the ratio of the Net Disbursements (current US$) of 2008 in Low & middle income to that in Low income?
Ensure brevity in your answer.  1.32. What is the ratio of the Net Disbursements (current US$) of 2005 in Low & middle income to that in Lower middle income?
Offer a very short reply. 1.66. What is the ratio of the Net Disbursements (current US$) in 2006 in Low & middle income to that in Lower middle income?
Give a very brief answer. 1.24. What is the ratio of the Net Disbursements (current US$) of 2007 in Low & middle income to that in Lower middle income?
Ensure brevity in your answer.  1.21. What is the ratio of the Net Disbursements (current US$) in 2008 in Low & middle income to that in Lower middle income?
Your response must be concise. 17.92. What is the ratio of the Net Disbursements (current US$) of 2005 in Low & middle income to that in Middle income?
Keep it short and to the point. 1.2. What is the ratio of the Net Disbursements (current US$) in 2006 in Low & middle income to that in Middle income?
Provide a succinct answer. 1.14. What is the ratio of the Net Disbursements (current US$) in 2007 in Low & middle income to that in Middle income?
Offer a very short reply. 1.08. What is the ratio of the Net Disbursements (current US$) in 2008 in Low & middle income to that in Middle income?
Offer a terse response. 4.15. What is the ratio of the Net Disbursements (current US$) of 2005 in Low income to that in Lower middle income?
Offer a terse response. 0.28. What is the ratio of the Net Disbursements (current US$) of 2006 in Low income to that in Lower middle income?
Give a very brief answer. 0.15. What is the ratio of the Net Disbursements (current US$) of 2007 in Low income to that in Lower middle income?
Offer a terse response. 0.09. What is the ratio of the Net Disbursements (current US$) of 2008 in Low income to that in Lower middle income?
Provide a short and direct response. 13.6. What is the ratio of the Net Disbursements (current US$) of 2005 in Low income to that in Middle income?
Offer a terse response. 0.2. What is the ratio of the Net Disbursements (current US$) of 2006 in Low income to that in Middle income?
Keep it short and to the point. 0.14. What is the ratio of the Net Disbursements (current US$) in 2007 in Low income to that in Middle income?
Make the answer very short. 0.08. What is the ratio of the Net Disbursements (current US$) in 2008 in Low income to that in Middle income?
Your answer should be very brief. 3.15. What is the ratio of the Net Disbursements (current US$) of 2005 in Lower middle income to that in Middle income?
Give a very brief answer. 0.72. What is the ratio of the Net Disbursements (current US$) of 2006 in Lower middle income to that in Middle income?
Your answer should be very brief. 0.92. What is the ratio of the Net Disbursements (current US$) in 2007 in Lower middle income to that in Middle income?
Keep it short and to the point. 0.89. What is the ratio of the Net Disbursements (current US$) in 2008 in Lower middle income to that in Middle income?
Offer a terse response. 0.23. What is the difference between the highest and the second highest Net Disbursements (current US$) in 2005?
Offer a terse response. 5.25e+06. What is the difference between the highest and the second highest Net Disbursements (current US$) in 2006?
Your answer should be very brief. 2.59e+06. What is the difference between the highest and the second highest Net Disbursements (current US$) in 2007?
Provide a succinct answer. 1.68e+06. What is the difference between the highest and the second highest Net Disbursements (current US$) in 2008?
Offer a terse response. 8.25e+06. What is the difference between the highest and the lowest Net Disbursements (current US$) of 2005?
Your answer should be compact. 2.62e+07. What is the difference between the highest and the lowest Net Disbursements (current US$) in 2006?
Make the answer very short. 1.84e+07. What is the difference between the highest and the lowest Net Disbursements (current US$) of 2007?
Give a very brief answer. 2.12e+07. What is the difference between the highest and the lowest Net Disbursements (current US$) of 2008?
Provide a succinct answer. 3.23e+07. 